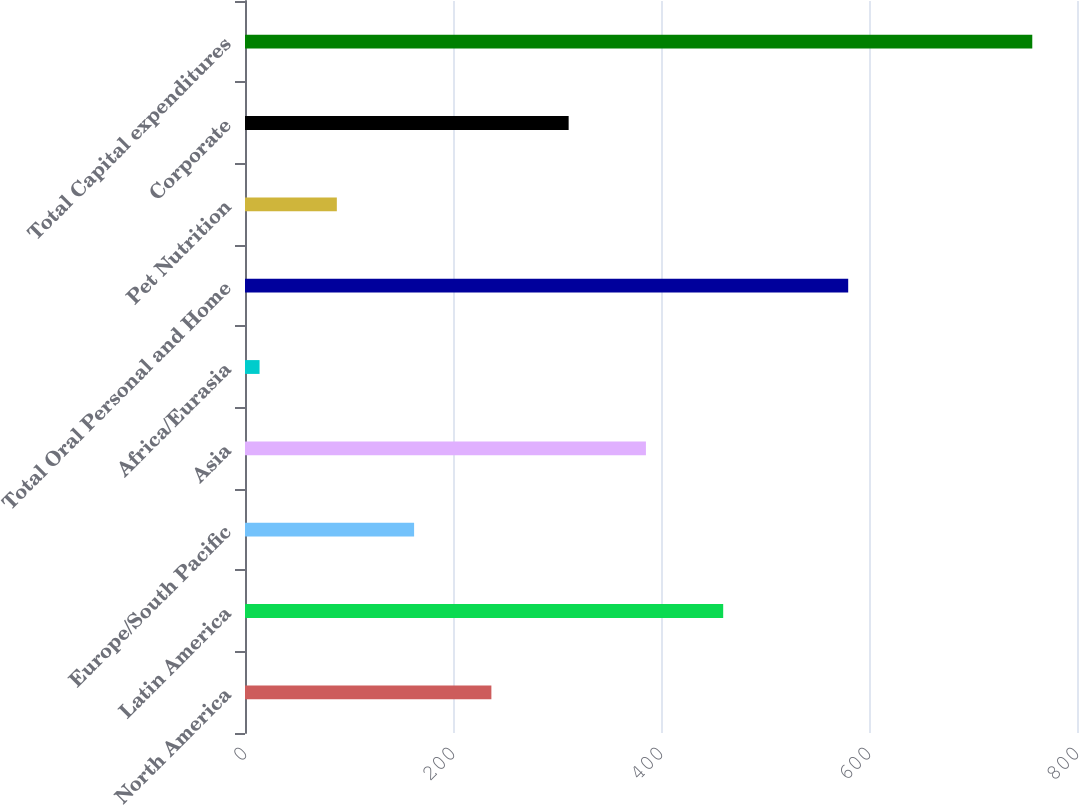Convert chart to OTSL. <chart><loc_0><loc_0><loc_500><loc_500><bar_chart><fcel>North America<fcel>Latin America<fcel>Europe/South Pacific<fcel>Asia<fcel>Africa/Eurasia<fcel>Total Oral Personal and Home<fcel>Pet Nutrition<fcel>Corporate<fcel>Total Capital expenditures<nl><fcel>236.9<fcel>459.8<fcel>162.6<fcel>385.5<fcel>14<fcel>580<fcel>88.3<fcel>311.2<fcel>757<nl></chart> 